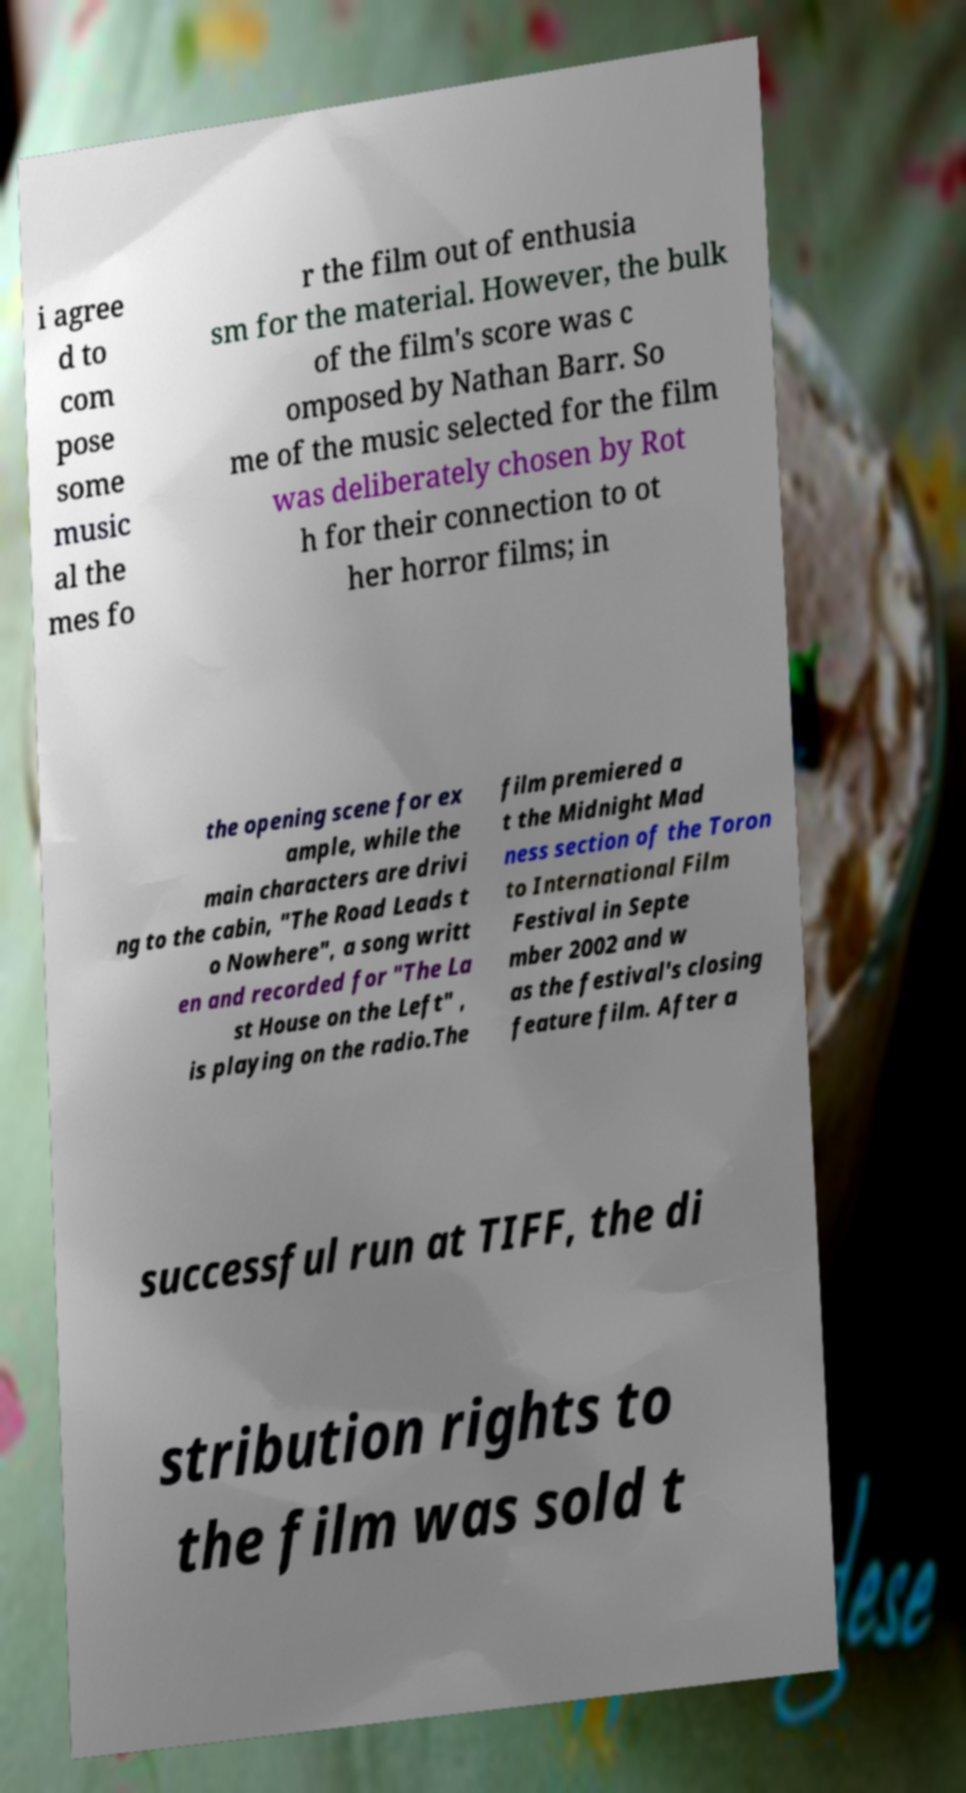I need the written content from this picture converted into text. Can you do that? i agree d to com pose some music al the mes fo r the film out of enthusia sm for the material. However, the bulk of the film's score was c omposed by Nathan Barr. So me of the music selected for the film was deliberately chosen by Rot h for their connection to ot her horror films; in the opening scene for ex ample, while the main characters are drivi ng to the cabin, "The Road Leads t o Nowhere", a song writt en and recorded for "The La st House on the Left" , is playing on the radio.The film premiered a t the Midnight Mad ness section of the Toron to International Film Festival in Septe mber 2002 and w as the festival's closing feature film. After a successful run at TIFF, the di stribution rights to the film was sold t 